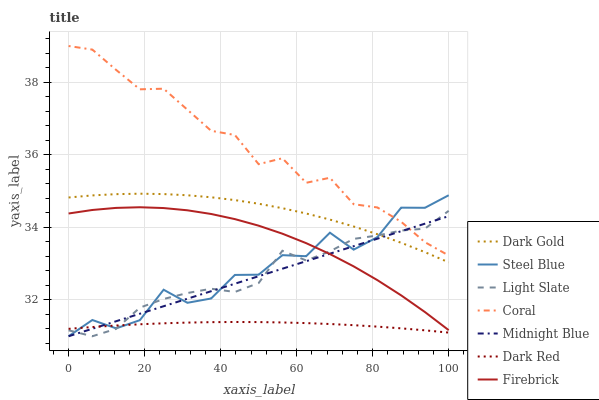Does Dark Red have the minimum area under the curve?
Answer yes or no. Yes. Does Coral have the maximum area under the curve?
Answer yes or no. Yes. Does Dark Gold have the minimum area under the curve?
Answer yes or no. No. Does Dark Gold have the maximum area under the curve?
Answer yes or no. No. Is Midnight Blue the smoothest?
Answer yes or no. Yes. Is Steel Blue the roughest?
Answer yes or no. Yes. Is Dark Gold the smoothest?
Answer yes or no. No. Is Dark Gold the roughest?
Answer yes or no. No. Does Midnight Blue have the lowest value?
Answer yes or no. Yes. Does Dark Gold have the lowest value?
Answer yes or no. No. Does Coral have the highest value?
Answer yes or no. Yes. Does Dark Gold have the highest value?
Answer yes or no. No. Is Dark Gold less than Coral?
Answer yes or no. Yes. Is Coral greater than Dark Gold?
Answer yes or no. Yes. Does Dark Red intersect Midnight Blue?
Answer yes or no. Yes. Is Dark Red less than Midnight Blue?
Answer yes or no. No. Is Dark Red greater than Midnight Blue?
Answer yes or no. No. Does Dark Gold intersect Coral?
Answer yes or no. No. 